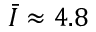<formula> <loc_0><loc_0><loc_500><loc_500>\bar { I } \approx 4 . 8</formula> 